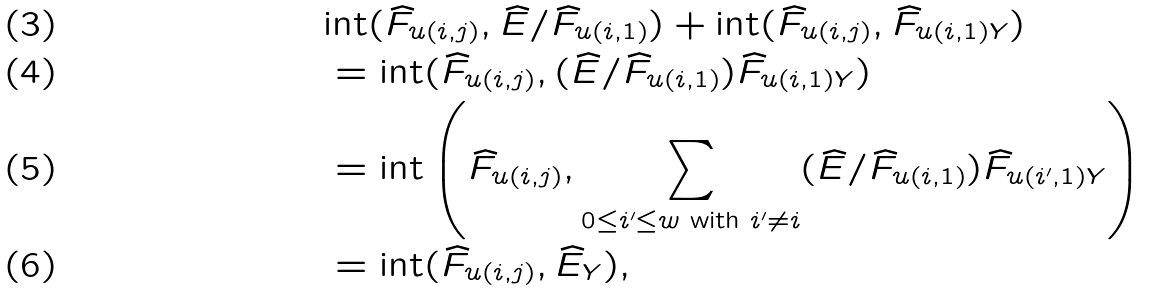Convert formula to latex. <formula><loc_0><loc_0><loc_500><loc_500>& \text {int} ( \widehat { F } _ { u ( i , j ) } , \widehat { E } / \widehat { F } _ { u ( i , 1 ) } ) + \text {int} ( \widehat { F } _ { u ( i , j ) } , \widehat { F } _ { u ( i , 1 ) Y } ) \\ & = \text {int} ( \widehat { F } _ { u ( i , j ) } , ( \widehat { E } / \widehat { F } _ { u ( i , 1 ) } ) \widehat { F } _ { u ( i , 1 ) Y } ) \\ & = \text {int} \left ( \widehat { F } _ { u ( i , j ) } , \sum _ { 0 \leq i ^ { \prime } \leq w \text { with } i ^ { \prime } \ne i } ( \widehat { E } / \widehat { F } _ { u ( i , 1 ) } ) \widehat { F } _ { u ( i ^ { \prime } , 1 ) Y } \right ) \\ & = \text {int} ( \widehat { F } _ { u ( i , j ) } , \widehat { E } _ { Y } ) ,</formula> 